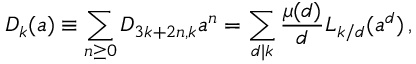<formula> <loc_0><loc_0><loc_500><loc_500>D _ { k } ( a ) \equiv \sum _ { n \geq 0 } D _ { 3 k + 2 n , k } a ^ { n } = \sum _ { d | k } \frac { \mu ( d ) } { d } L _ { k / d } ( a ^ { d } ) \, ,</formula> 